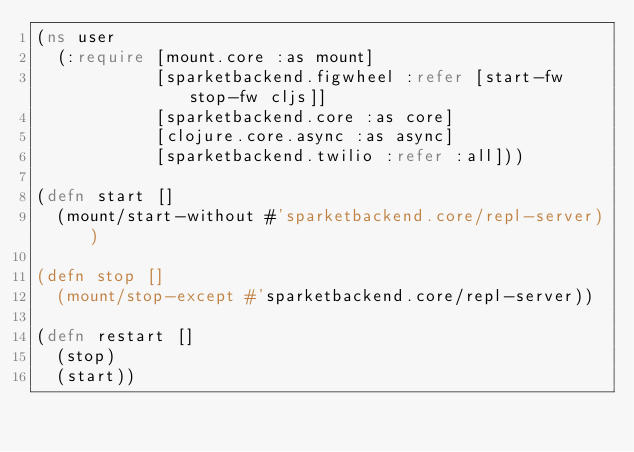<code> <loc_0><loc_0><loc_500><loc_500><_Clojure_>(ns user
  (:require [mount.core :as mount]
            [sparketbackend.figwheel :refer [start-fw stop-fw cljs]]
            [sparketbackend.core :as core]
            [clojure.core.async :as async]
            [sparketbackend.twilio :refer :all]))

(defn start []
  (mount/start-without #'sparketbackend.core/repl-server))

(defn stop []
  (mount/stop-except #'sparketbackend.core/repl-server))

(defn restart []
  (stop)
  (start))


</code> 